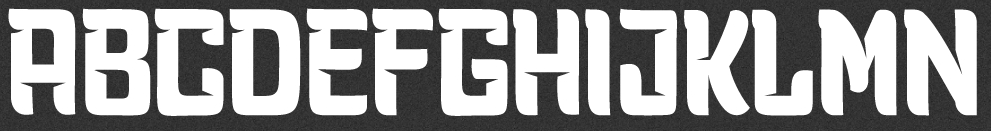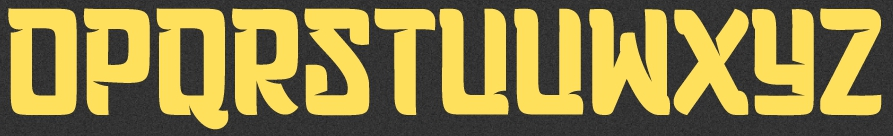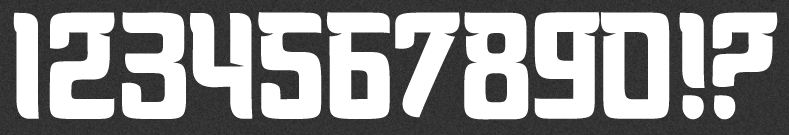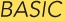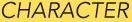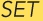What text is displayed in these images sequentially, separated by a semicolon? ABCDEFGHIJKLMN; OPQRSTUVWXYZ; 1234567890!?; BASIC; CHARACTER; SET 